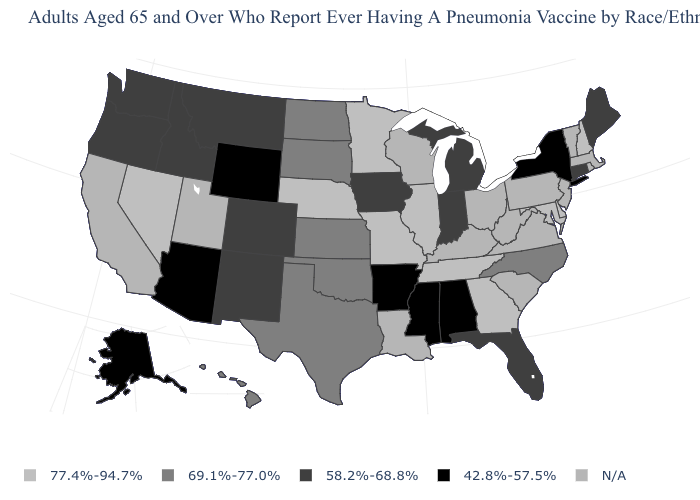Name the states that have a value in the range N/A?
Quick response, please. California, Kentucky, Louisiana, Massachusetts, New Jersey, Ohio, Pennsylvania, Rhode Island, South Carolina, Utah, Vermont, Virginia, West Virginia, Wisconsin. What is the lowest value in the West?
Short answer required. 42.8%-57.5%. What is the value of California?
Keep it brief. N/A. Name the states that have a value in the range 42.8%-57.5%?
Be succinct. Alabama, Alaska, Arizona, Arkansas, Mississippi, New York, Wyoming. Does Arizona have the lowest value in the USA?
Quick response, please. Yes. Name the states that have a value in the range 77.4%-94.7%?
Short answer required. Delaware, Georgia, Illinois, Maryland, Minnesota, Missouri, Nebraska, Nevada, New Hampshire, Tennessee. How many symbols are there in the legend?
Write a very short answer. 5. How many symbols are there in the legend?
Keep it brief. 5. What is the highest value in the USA?
Concise answer only. 77.4%-94.7%. What is the value of Vermont?
Answer briefly. N/A. Name the states that have a value in the range 42.8%-57.5%?
Write a very short answer. Alabama, Alaska, Arizona, Arkansas, Mississippi, New York, Wyoming. What is the value of New Jersey?
Write a very short answer. N/A. Does the first symbol in the legend represent the smallest category?
Give a very brief answer. No. 